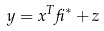Convert formula to latex. <formula><loc_0><loc_0><loc_500><loc_500>y = x ^ { T } \beta ^ { * } + z</formula> 